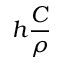<formula> <loc_0><loc_0><loc_500><loc_500>h \frac { C } { \rho }</formula> 